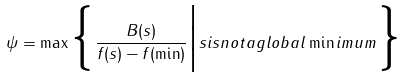Convert formula to latex. <formula><loc_0><loc_0><loc_500><loc_500>\psi = \max \Big \{ \frac { B ( s ) } { f ( s ) - f ( \min ) } \Big | s i s n o t a g l o b a l \min i m u m \Big \}</formula> 